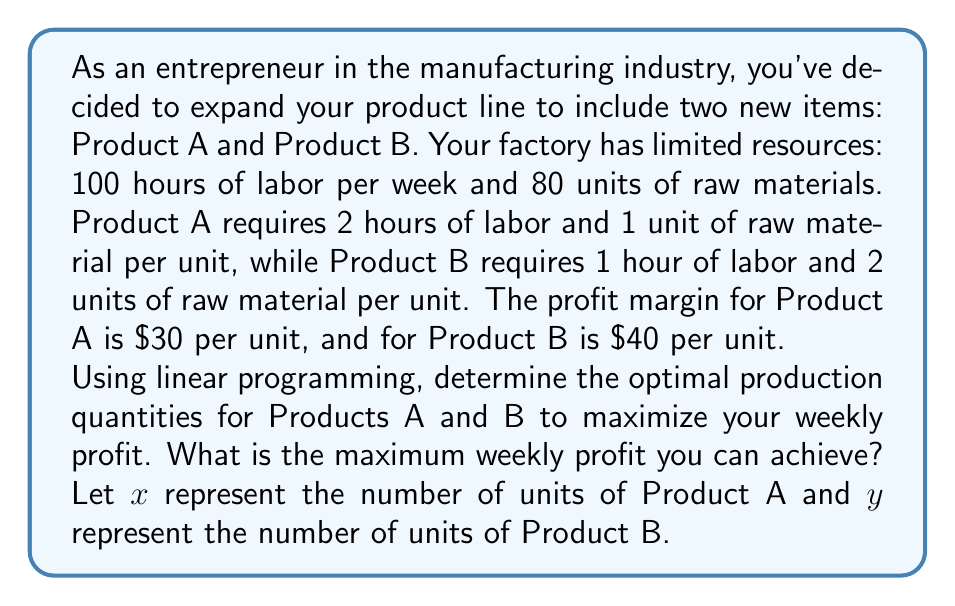Solve this math problem. To solve this linear programming problem, we'll follow these steps:

1. Define the objective function
2. Identify the constraints
3. Set up the linear programming model
4. Solve using the graphical method

Step 1: Define the objective function
The objective is to maximize profit. Let P be the total profit.
$$ P = 30x + 40y $$

Step 2: Identify the constraints
Labor constraint: $2x + y \leq 100$
Raw material constraint: $x + 2y \leq 80$
Non-negativity constraints: $x \geq 0, y \geq 0$

Step 3: Set up the linear programming model
Maximize $P = 30x + 40y$
Subject to:
$2x + y \leq 100$
$x + 2y \leq 80$
$x \geq 0, y \geq 0$

Step 4: Solve using the graphical method
a) Plot the constraints:
[asy]
unitsize(2mm);
defaultpen(fontsize(10pt));

draw((0,0)--(50,0), arrow=Arrow(TeXHead));
draw((0,0)--(0,50), arrow=Arrow(TeXHead));

label("x", (50,0), E);
label("y", (0,50), N);

draw((0,100)--(50,0), blue);
draw((0,40)--(80,0), red);

label("2x + y = 100", (25,50), NW, blue);
label("x + 2y = 80", (40,20), SE, red);

fill((0,0)--(0,40)--(26.67,26.67)--(50,0)--cycle, black+opacity(0.1));

dot((0,40));
dot((26.67,26.67));
dot((50,0));

label("(0,40)", (0,40), W);
label("(26.67,26.67)", (26.67,26.67), NE);
label("(50,0)", (50,0), S);
[/asy]

b) Identify the corner points of the feasible region:
(0,0), (0,40), (26.67,26.67), (50,0)

c) Evaluate the objective function at each corner point:
(0,0): P = 0
(0,40): P = 40 * 40 = 1600
(26.67,26.67): P = 30 * 26.67 + 40 * 26.67 = 1866.9
(50,0): P = 30 * 50 = 1500

The maximum profit occurs at the point (26.67, 26.67).
Answer: The optimal production quantities are approximately 26.67 units of Product A and 26.67 units of Product B, resulting in a maximum weekly profit of $1,866.90. 